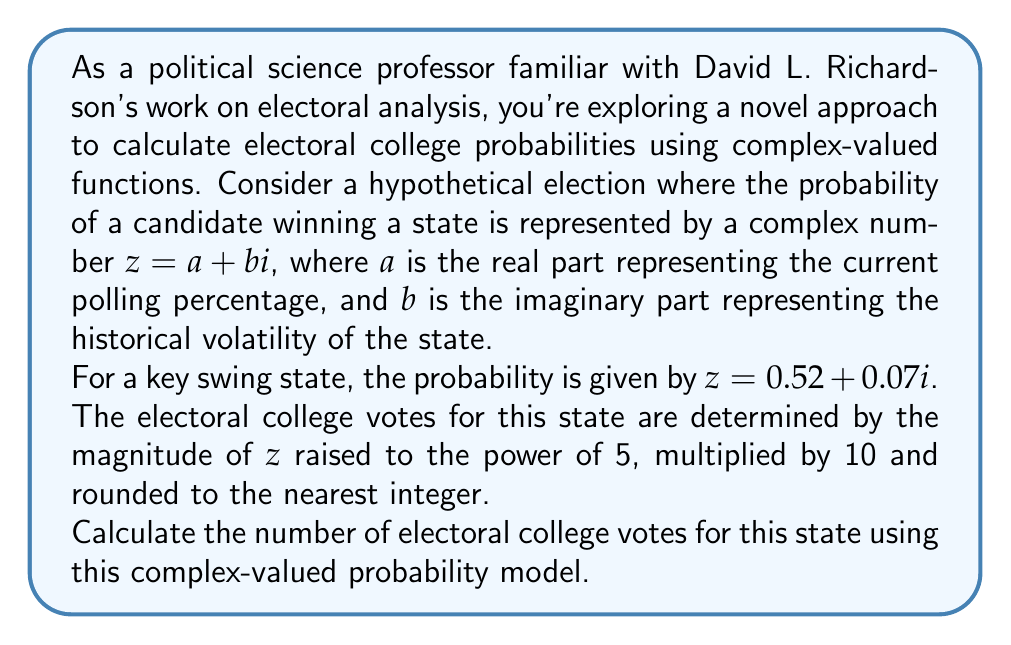What is the answer to this math problem? To solve this problem, we need to follow these steps:

1) First, recall that the magnitude of a complex number $z = a + bi$ is given by:

   $|z| = \sqrt{a^2 + b^2}$

2) In this case, $z = 0.52 + 0.07i$, so:

   $|z| = \sqrt{0.52^2 + 0.07^2} = \sqrt{0.2704 + 0.0049} = \sqrt{0.2753} \approx 0.5247$

3) Now, we need to raise this magnitude to the power of 5:

   $|z|^5 \approx 0.5247^5 \approx 0.0418$

4) Next, multiply this result by 10:

   $0.0418 \times 10 \approx 0.418$

5) Finally, round this to the nearest integer:

   $\text{round}(0.418) = 0$

However, since electoral college votes cannot be zero, we assume a minimum of 1 vote for any state.
Answer: 1 electoral college vote 